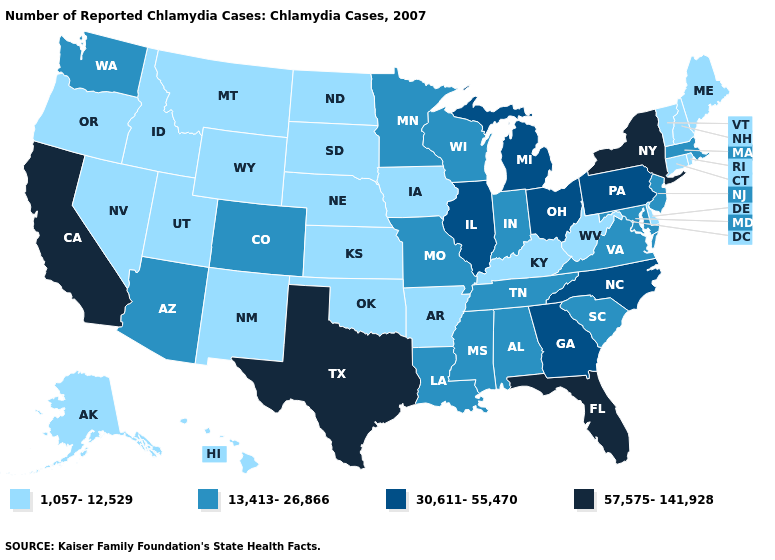Does Nebraska have the lowest value in the MidWest?
Keep it brief. Yes. Does New York have the highest value in the USA?
Write a very short answer. Yes. What is the lowest value in the USA?
Answer briefly. 1,057-12,529. Among the states that border Mississippi , which have the lowest value?
Concise answer only. Arkansas. Does Kansas have the lowest value in the MidWest?
Concise answer only. Yes. Name the states that have a value in the range 1,057-12,529?
Give a very brief answer. Alaska, Arkansas, Connecticut, Delaware, Hawaii, Idaho, Iowa, Kansas, Kentucky, Maine, Montana, Nebraska, Nevada, New Hampshire, New Mexico, North Dakota, Oklahoma, Oregon, Rhode Island, South Dakota, Utah, Vermont, West Virginia, Wyoming. Which states have the lowest value in the MidWest?
Concise answer only. Iowa, Kansas, Nebraska, North Dakota, South Dakota. Among the states that border Vermont , does New York have the lowest value?
Answer briefly. No. Among the states that border Delaware , which have the lowest value?
Write a very short answer. Maryland, New Jersey. Does Indiana have the lowest value in the USA?
Quick response, please. No. Does Illinois have the highest value in the MidWest?
Write a very short answer. Yes. Among the states that border New Jersey , which have the highest value?
Answer briefly. New York. What is the highest value in the West ?
Give a very brief answer. 57,575-141,928. Name the states that have a value in the range 1,057-12,529?
Give a very brief answer. Alaska, Arkansas, Connecticut, Delaware, Hawaii, Idaho, Iowa, Kansas, Kentucky, Maine, Montana, Nebraska, Nevada, New Hampshire, New Mexico, North Dakota, Oklahoma, Oregon, Rhode Island, South Dakota, Utah, Vermont, West Virginia, Wyoming. 